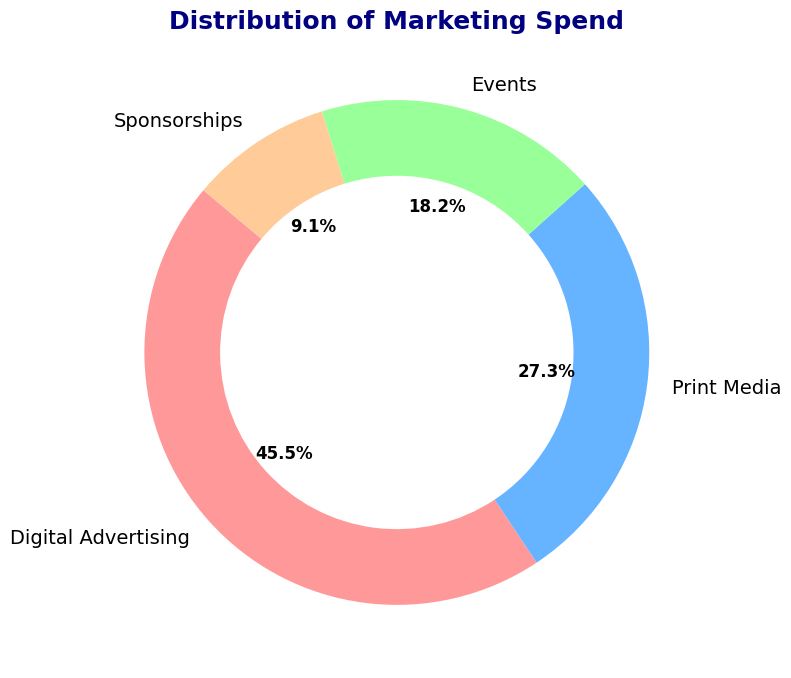What percentage of the marketing spend is allocated to Digital Advertising? To find this, look at the pie chart and locate the slice that refers to Digital Advertising. The chart shows the percentage as 50%.
Answer: 50% Which category has the smallest allocation? Look for the smallest slice in the pie chart. This slice is labeled Sponsorships, which corresponds to 10%.
Answer: Sponsorships What is the total spend for Print Media and Events combined? First, find the spend for each category from the chart: Print Media is 750,000 and Events is 500,000. Summing them gives 750,000 + 500,000 = 1,250,000.
Answer: 1,250,000 How does the spend for Print Media compare to that of Sponsorships? Compare the two slices' sizes in the pie chart. Print Media's spend is greater than Sponsorships: 750,000 compared to 250,000.
Answer: Print Media's spend is greater What is the difference in spend between Digital Advertising and Events? The spend for Digital Advertising is 1,250,000, and for Events, it is 500,000. Subtract the Events spend from Digital Advertising: 1,250,000 - 500,000 = 750,000.
Answer: 750,000 What percentage of the total marketing spend is allocated to Print Media and Sponsorships combined? Print Media accounts for 30% and Sponsorships for 10%, according to the chart. Adding them gives 30% + 10% = 40%.
Answer: 40% Which two categories have a combined spend greater than Digital Advertising? Compare the combined spends: Both Print Media + Events (750,000 + 500,000 = 1,250,000) and Print Media + Sponsorships (750,000 + 250,000 = 1,000,000) are greater than Digital Advertising (1,250,000).
Answer: Print Media and Events What is the ratio of spend between Digital Advertising to Sponsorships? The spend for Digital Advertising is 1,250,000 and for Sponsorships is 250,000. The ratio is 1,250,000:250,000, which simplifies to 5:1.
Answer: 5:1 If the total marketing budget is 3,000,000, what is the exact spend for each category? Use the given percentages from the pie chart: Digital Advertising 50%, Print Media 30%, Events 20%, Sponsorships 10%. Calculating each: Digital Advertising: 3,000,000 * 0.50 = 1,500,000; Print Media: 3,000,000 * 0.30 = 900,000; Events: 3,000,000 * 0.20 = 600,000; Sponsorships: 3,000,000 * 0.10 = 300,000.
Answer: Digital Advertising: 1,500,000; Print Media: 900,000; Events: 600,000; Sponsorships: 300,000 